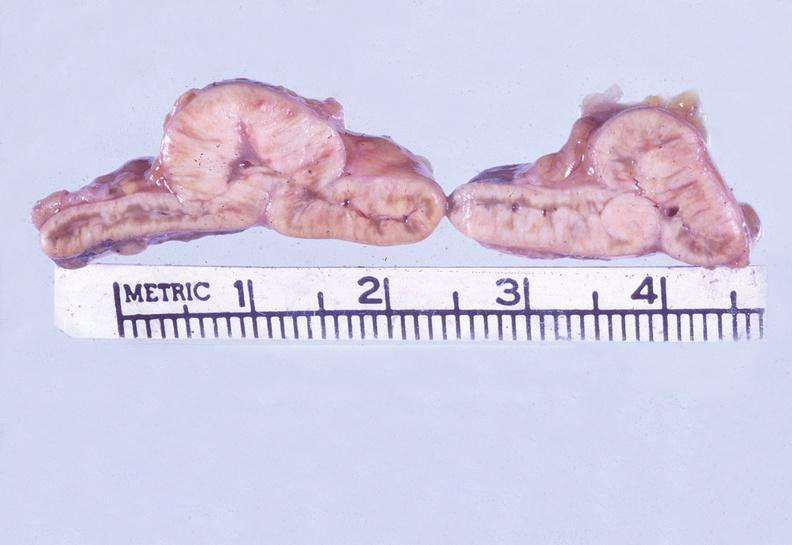does this image shows of smooth muscle cell with lipid in sarcoplasm and lipid show adrenal, metastatic gastric carcinoma, diffuse?
Answer the question using a single word or phrase. No 